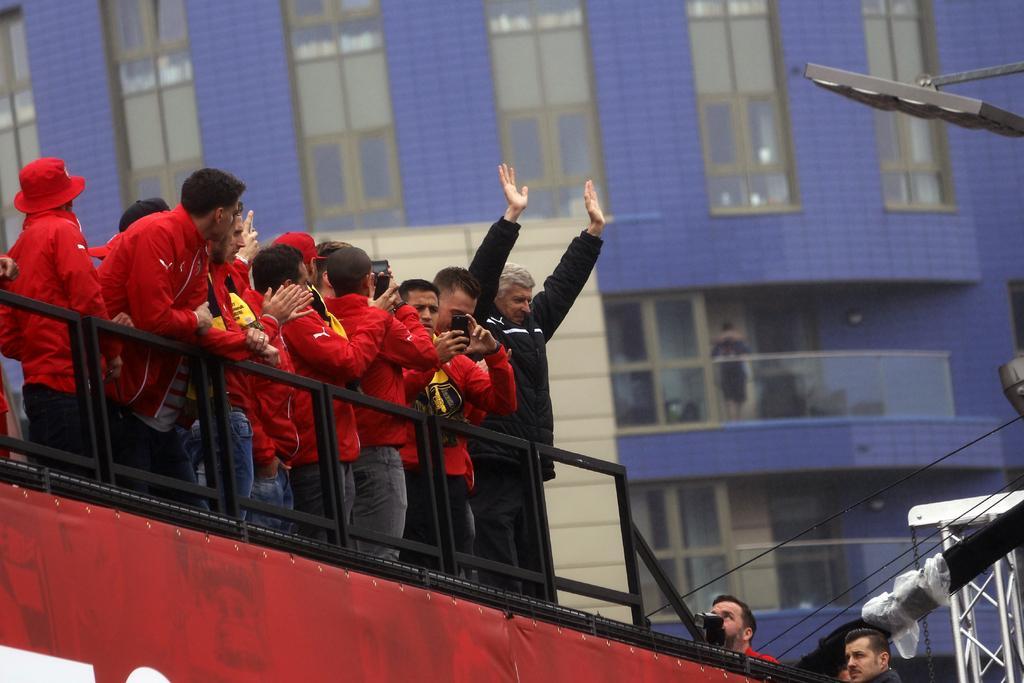Describe this image in one or two sentences. In this image I can see some people are standing on the vehicle. In the background, I can see the building with windows. 